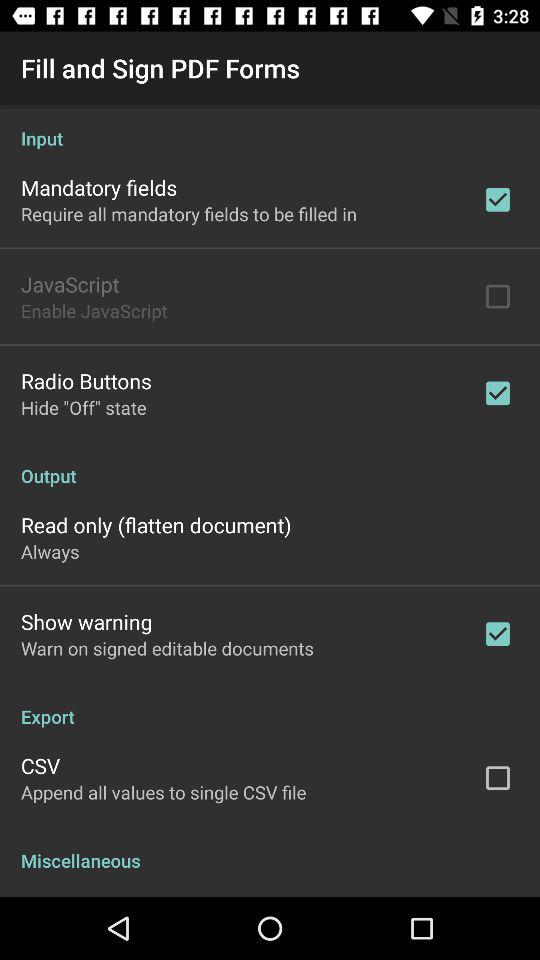Which option is checked marked? The options that is checked marked are "Mandatory fields", "Radio Buttons" and "Show warning". 